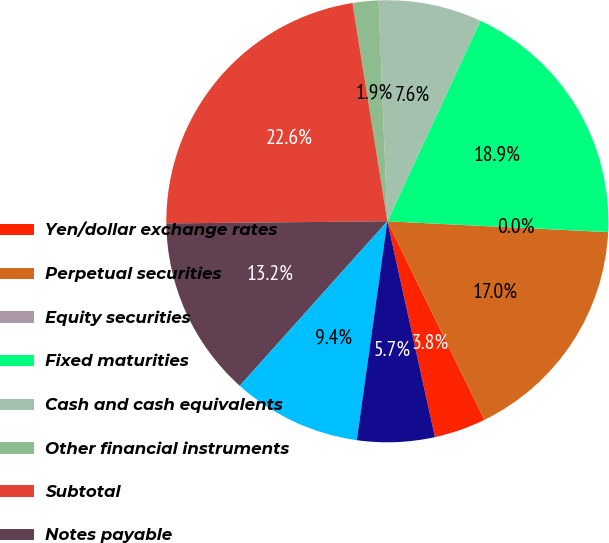Convert chart. <chart><loc_0><loc_0><loc_500><loc_500><pie_chart><fcel>Yen/dollar exchange rates<fcel>Perpetual securities<fcel>Equity securities<fcel>Fixed maturities<fcel>Cash and cash equivalents<fcel>Other financial instruments<fcel>Subtotal<fcel>Notes payable<fcel>Cross-currency swaps<fcel>Japanese policyholder<nl><fcel>3.78%<fcel>16.98%<fcel>0.01%<fcel>18.86%<fcel>7.55%<fcel>1.89%<fcel>22.63%<fcel>13.21%<fcel>9.43%<fcel>5.66%<nl></chart> 